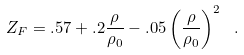Convert formula to latex. <formula><loc_0><loc_0><loc_500><loc_500>Z _ { F } = . 5 7 + . 2 \frac { \rho } { \rho _ { 0 } } - . 0 5 \left ( \frac { \rho } { \rho _ { 0 } } \right ) ^ { 2 } \ .</formula> 